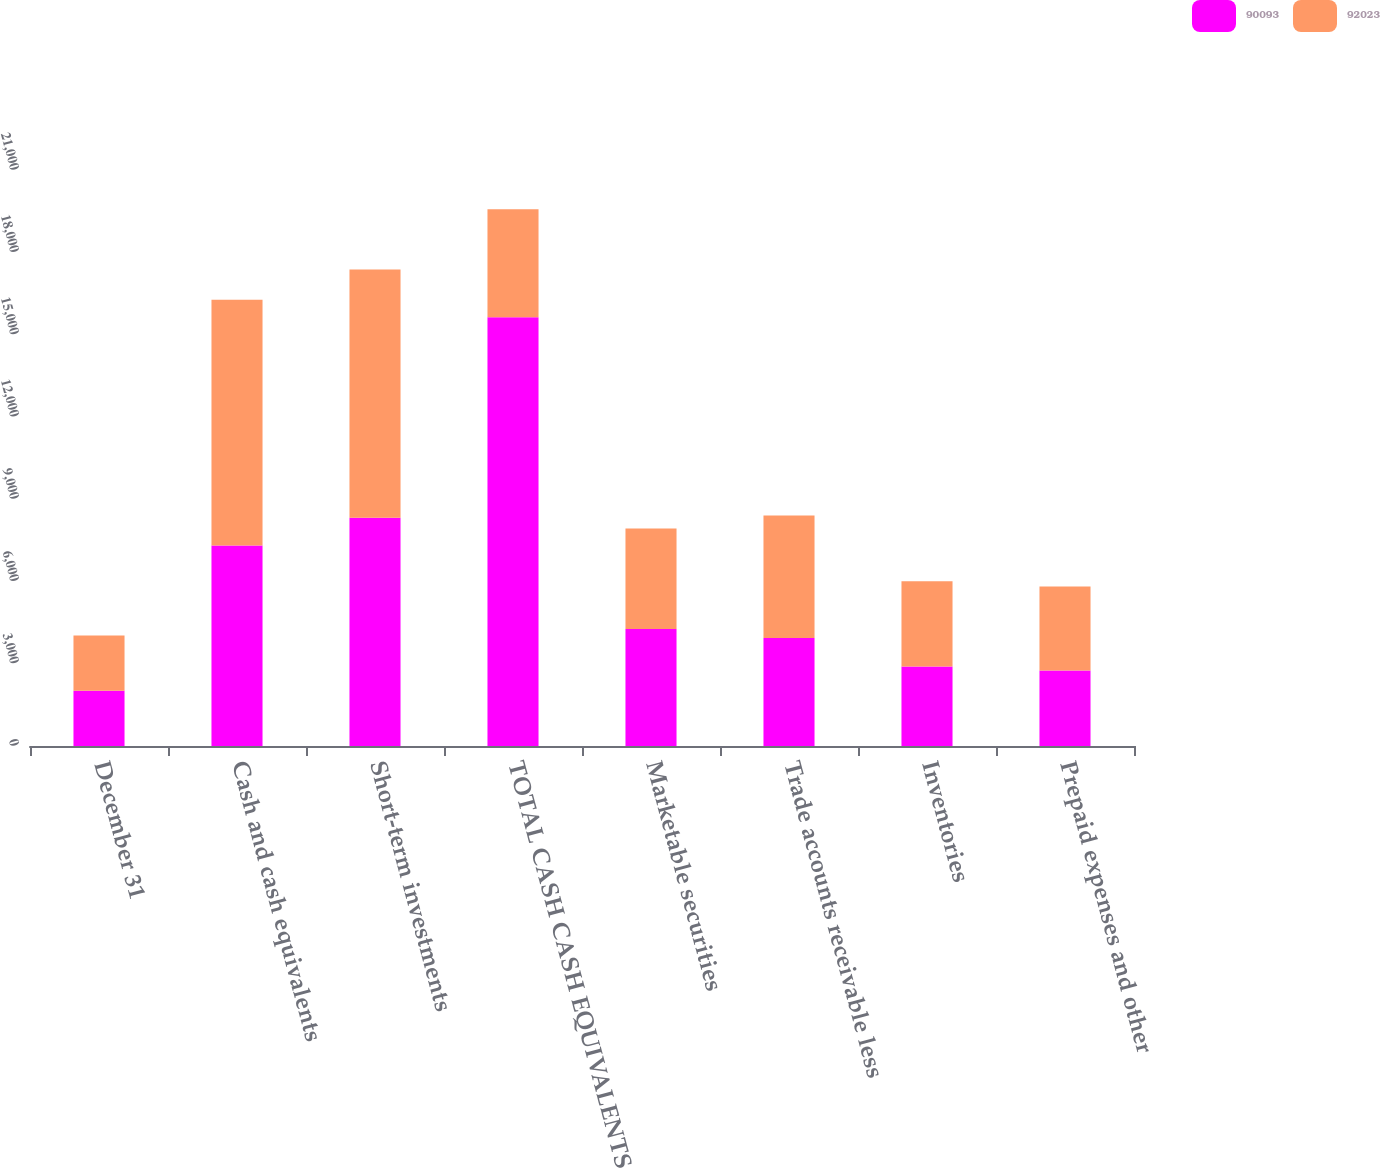<chart> <loc_0><loc_0><loc_500><loc_500><stacked_bar_chart><ecel><fcel>December 31<fcel>Cash and cash equivalents<fcel>Short-term investments<fcel>TOTAL CASH CASH EQUIVALENTS<fcel>Marketable securities<fcel>Trade accounts receivable less<fcel>Inventories<fcel>Prepaid expenses and other<nl><fcel>90093<fcel>2015<fcel>7309<fcel>8322<fcel>15631<fcel>4269<fcel>3941<fcel>2902<fcel>2752<nl><fcel>92023<fcel>2014<fcel>8958<fcel>9052<fcel>3941<fcel>3665<fcel>4466<fcel>3100<fcel>3066<nl></chart> 